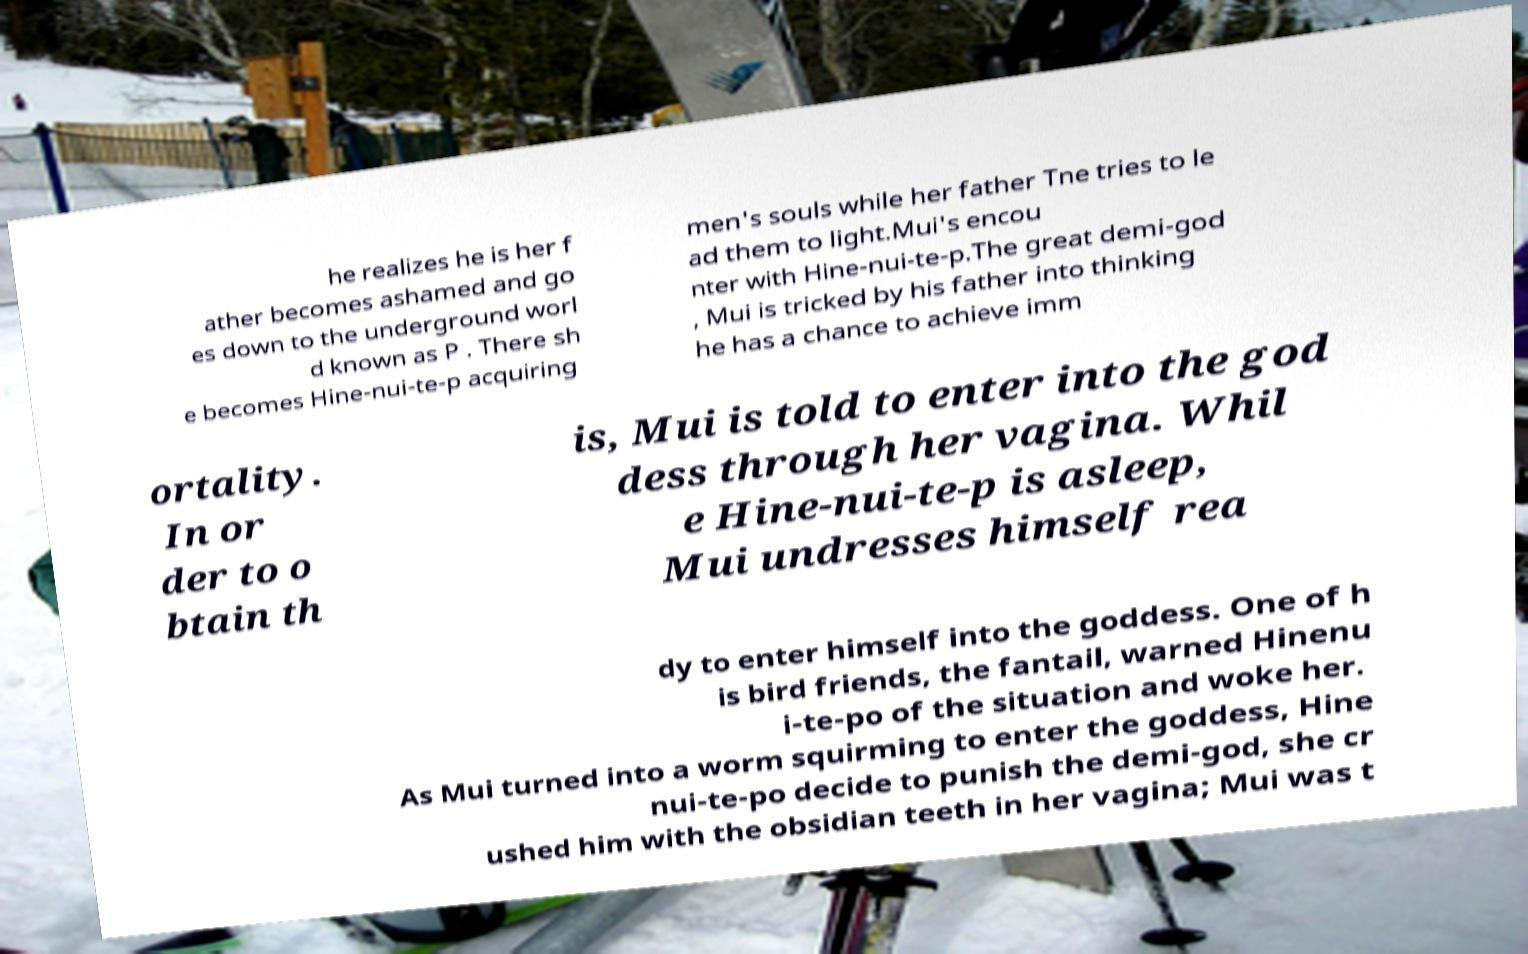Could you extract and type out the text from this image? he realizes he is her f ather becomes ashamed and go es down to the underground worl d known as P . There sh e becomes Hine-nui-te-p acquiring men's souls while her father Tne tries to le ad them to light.Mui's encou nter with Hine-nui-te-p.The great demi-god , Mui is tricked by his father into thinking he has a chance to achieve imm ortality. In or der to o btain th is, Mui is told to enter into the god dess through her vagina. Whil e Hine-nui-te-p is asleep, Mui undresses himself rea dy to enter himself into the goddess. One of h is bird friends, the fantail, warned Hinenu i-te-po of the situation and woke her. As Mui turned into a worm squirming to enter the goddess, Hine nui-te-po decide to punish the demi-god, she cr ushed him with the obsidian teeth in her vagina; Mui was t 